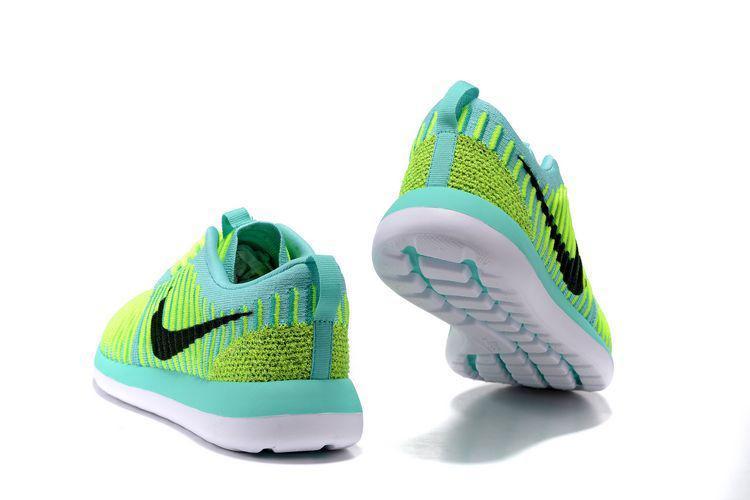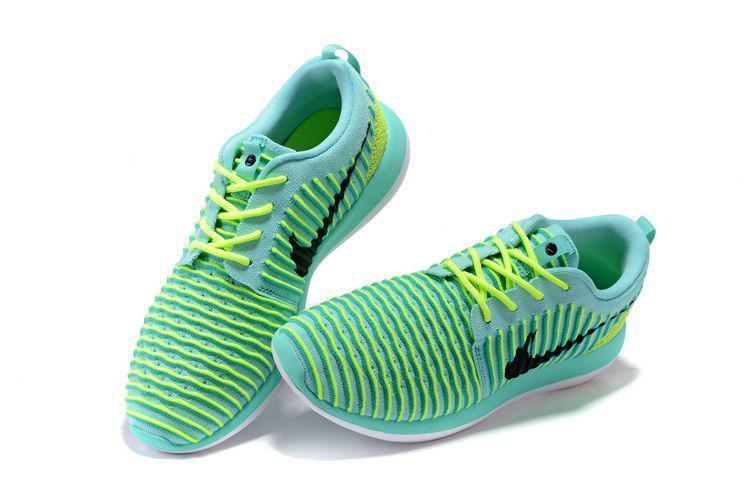The first image is the image on the left, the second image is the image on the right. For the images displayed, is the sentence "A pair of shoes, side by side, in one image is a varigated stripe design with a different weave on the heel area and two-toned soles, while a second image shows just one shoe of a similar design, but in a different color." factually correct? Answer yes or no. No. The first image is the image on the left, the second image is the image on the right. Evaluate the accuracy of this statement regarding the images: "An image contains at least one green sports shoe.". Is it true? Answer yes or no. Yes. 